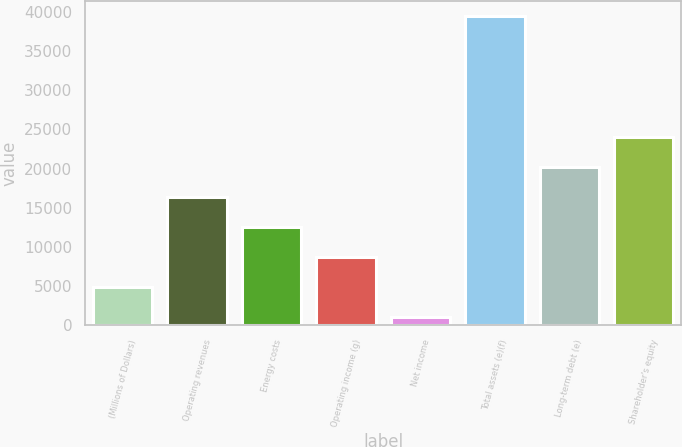<chart> <loc_0><loc_0><loc_500><loc_500><bar_chart><fcel>(Millions of Dollars)<fcel>Operating revenues<fcel>Energy costs<fcel>Operating income (g)<fcel>Net income<fcel>Total assets (e)(f)<fcel>Long-term debt (e)<fcel>Shareholder's equity<nl><fcel>4896.5<fcel>16412<fcel>12573.5<fcel>8735<fcel>1058<fcel>39443<fcel>20250.5<fcel>24089<nl></chart> 